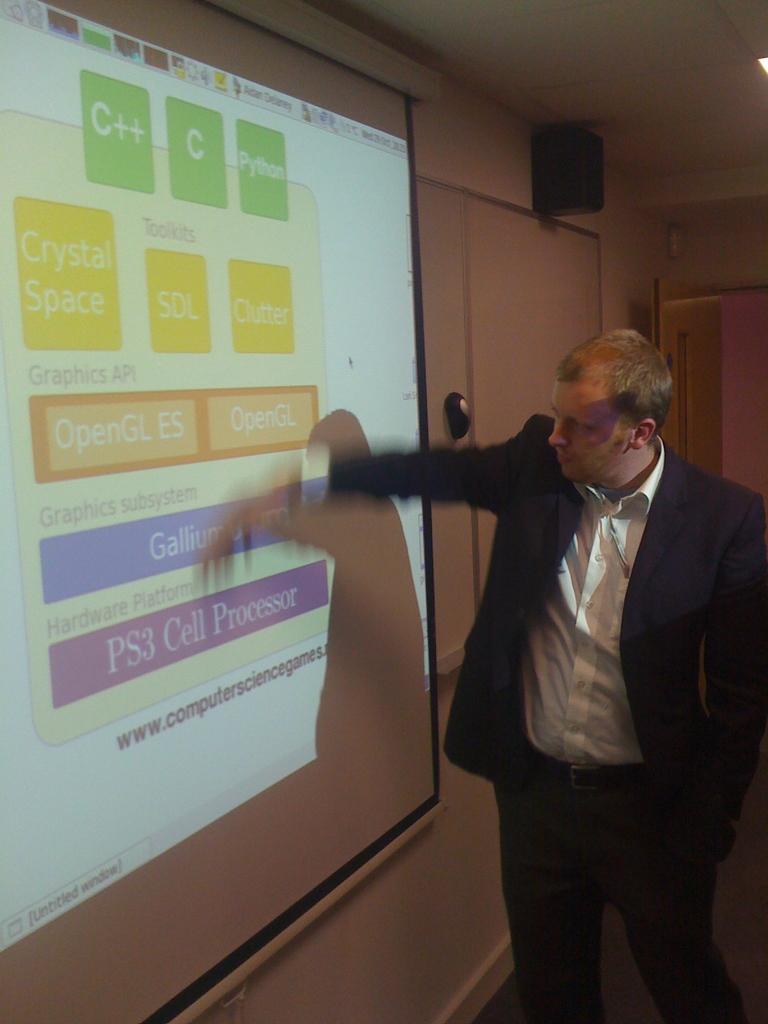What do the green squares say?
Offer a very short reply. C++ c python. 